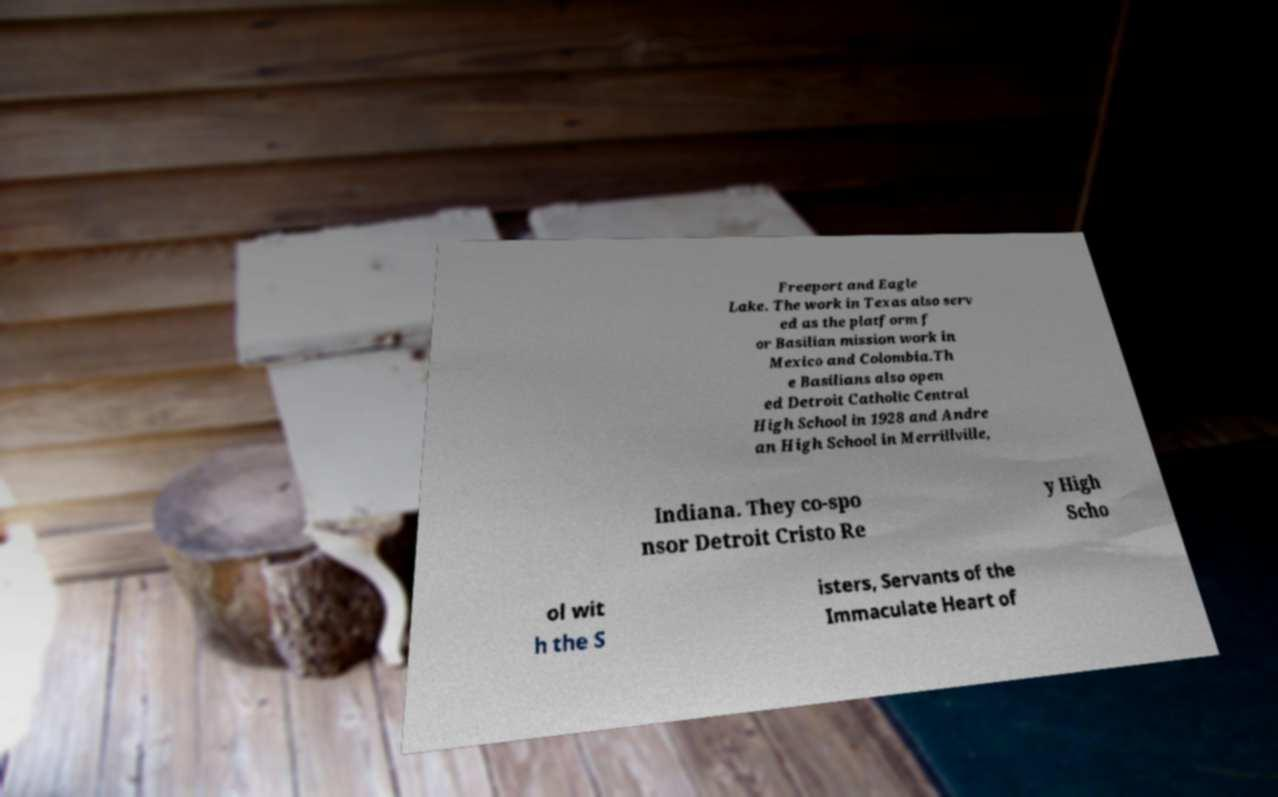Can you read and provide the text displayed in the image?This photo seems to have some interesting text. Can you extract and type it out for me? Freeport and Eagle Lake. The work in Texas also serv ed as the platform f or Basilian mission work in Mexico and Colombia.Th e Basilians also open ed Detroit Catholic Central High School in 1928 and Andre an High School in Merrillville, Indiana. They co-spo nsor Detroit Cristo Re y High Scho ol wit h the S isters, Servants of the Immaculate Heart of 